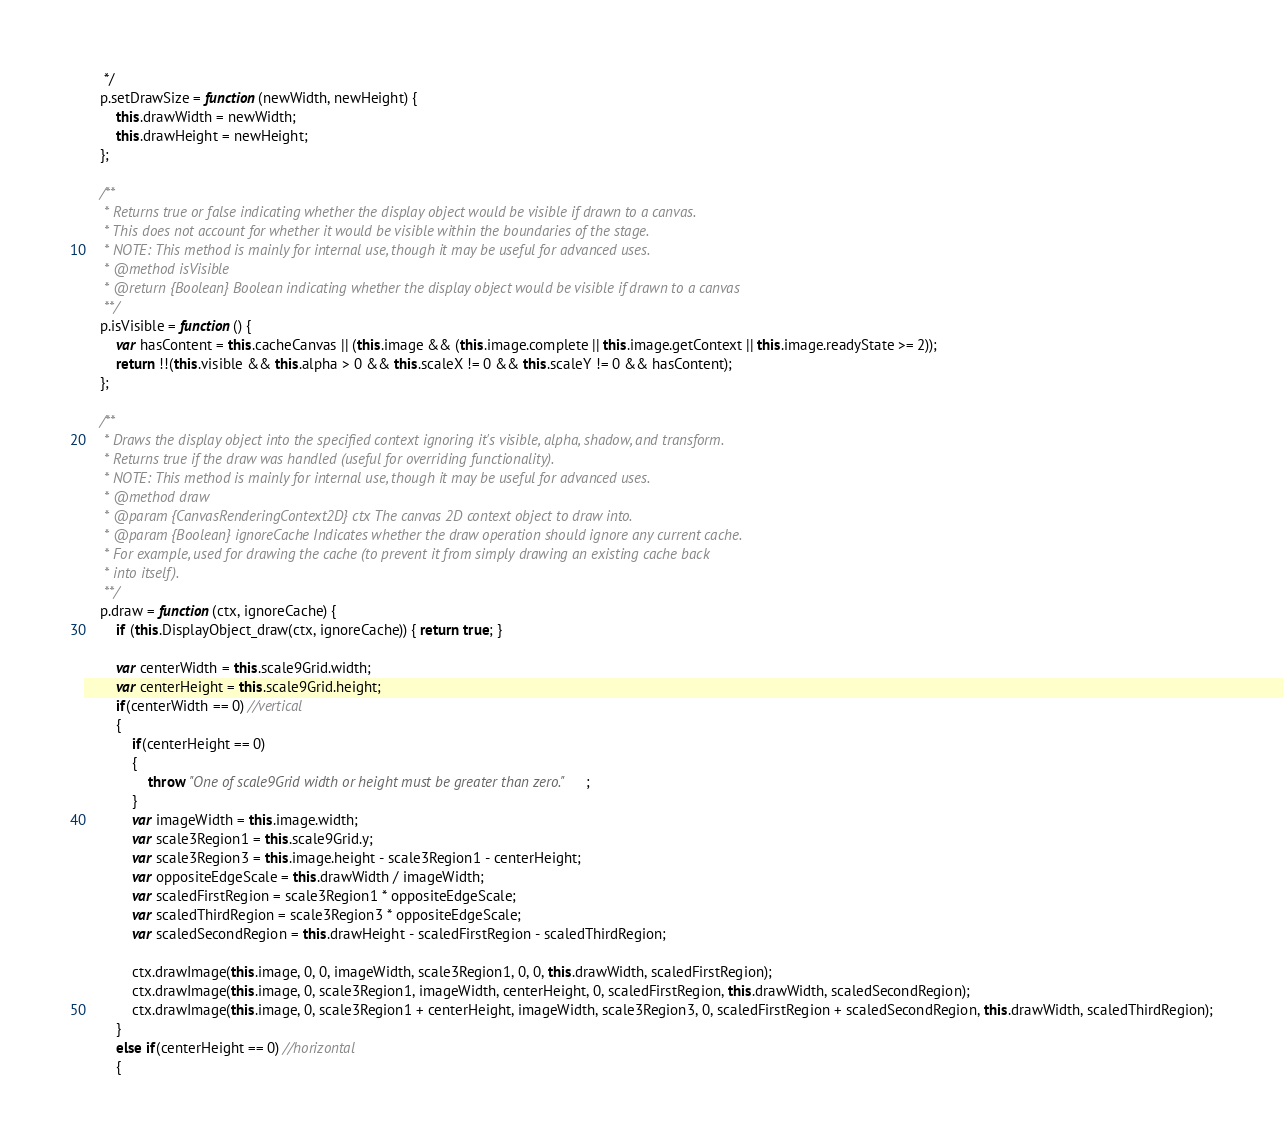<code> <loc_0><loc_0><loc_500><loc_500><_JavaScript_>	 */
	p.setDrawSize = function(newWidth, newHeight) {
		this.drawWidth = newWidth;
		this.drawHeight = newHeight;
	};

	/**
	 * Returns true or false indicating whether the display object would be visible if drawn to a canvas.
	 * This does not account for whether it would be visible within the boundaries of the stage.
	 * NOTE: This method is mainly for internal use, though it may be useful for advanced uses.
	 * @method isVisible
	 * @return {Boolean} Boolean indicating whether the display object would be visible if drawn to a canvas
	 **/
	p.isVisible = function() {
		var hasContent = this.cacheCanvas || (this.image && (this.image.complete || this.image.getContext || this.image.readyState >= 2));
		return !!(this.visible && this.alpha > 0 && this.scaleX != 0 && this.scaleY != 0 && hasContent);
	};

	/**
	 * Draws the display object into the specified context ignoring it's visible, alpha, shadow, and transform.
	 * Returns true if the draw was handled (useful for overriding functionality).
	 * NOTE: This method is mainly for internal use, though it may be useful for advanced uses.
	 * @method draw
	 * @param {CanvasRenderingContext2D} ctx The canvas 2D context object to draw into.
	 * @param {Boolean} ignoreCache Indicates whether the draw operation should ignore any current cache.
	 * For example, used for drawing the cache (to prevent it from simply drawing an existing cache back
	 * into itself).
	 **/
	p.draw = function(ctx, ignoreCache) {
		if (this.DisplayObject_draw(ctx, ignoreCache)) { return true; }

		var centerWidth = this.scale9Grid.width;
		var centerHeight = this.scale9Grid.height;
		if(centerWidth == 0) //vertical
		{
			if(centerHeight == 0)
			{
				throw "One of scale9Grid width or height must be greater than zero.";
			}
			var imageWidth = this.image.width;
			var scale3Region1 = this.scale9Grid.y;
			var scale3Region3 = this.image.height - scale3Region1 - centerHeight;
			var oppositeEdgeScale = this.drawWidth / imageWidth;
			var scaledFirstRegion = scale3Region1 * oppositeEdgeScale;
			var scaledThirdRegion = scale3Region3 * oppositeEdgeScale;
			var scaledSecondRegion = this.drawHeight - scaledFirstRegion - scaledThirdRegion;

			ctx.drawImage(this.image, 0, 0, imageWidth, scale3Region1, 0, 0, this.drawWidth, scaledFirstRegion);
			ctx.drawImage(this.image, 0, scale3Region1, imageWidth, centerHeight, 0, scaledFirstRegion, this.drawWidth, scaledSecondRegion);
			ctx.drawImage(this.image, 0, scale3Region1 + centerHeight, imageWidth, scale3Region3, 0, scaledFirstRegion + scaledSecondRegion, this.drawWidth, scaledThirdRegion);
		}
		else if(centerHeight == 0) //horizontal
		{</code> 